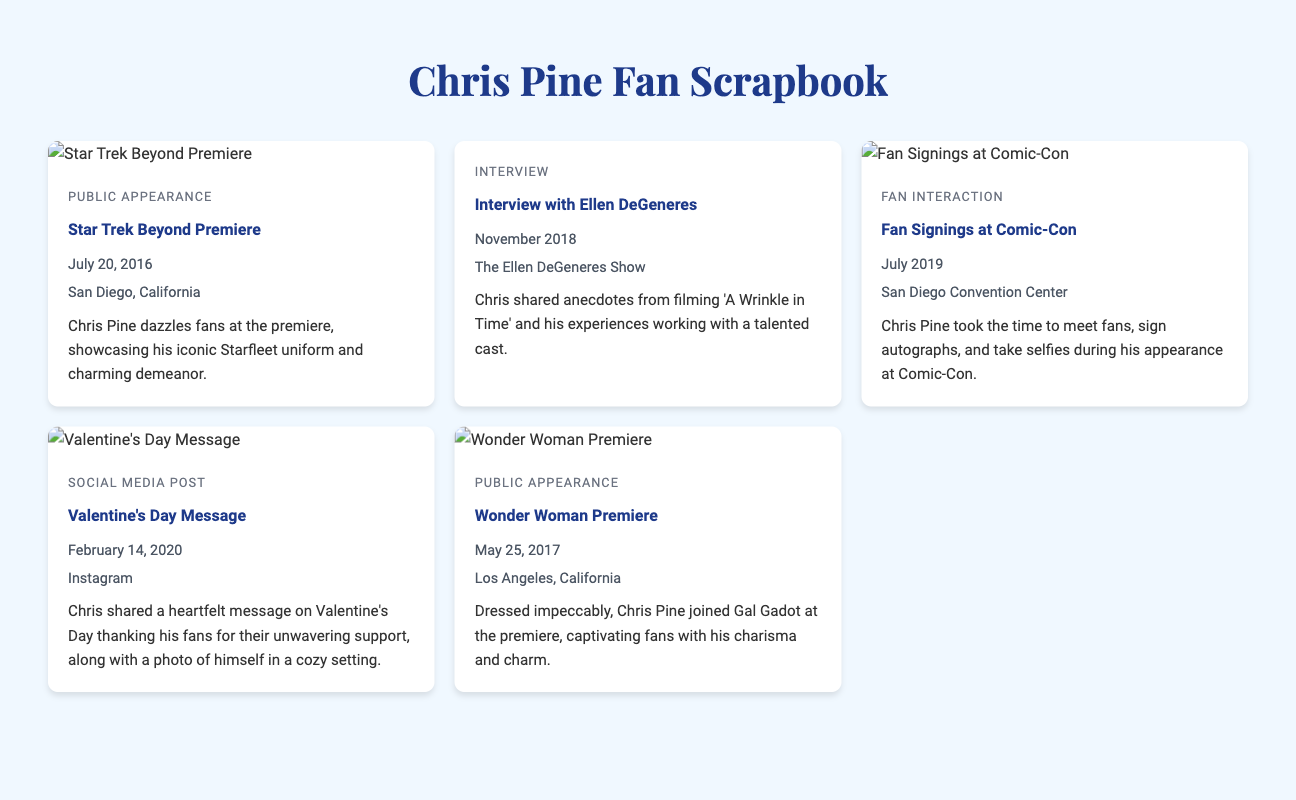What was the date of the Star Trek Beyond Premiere? The date is provided in the scrapbook item for the Star Trek Beyond Premiere.
Answer: July 20, 2016 Where did the Fan Signings at Comic-Con take place? The location is mentioned in the scrapbook item for the Fan Signings at Comic-Con.
Answer: San Diego Convention Center Which TV show featured Chris Pine in an interview in November 2018? The scrapbook item for the interview indicates the TV show he appeared on.
Answer: The Ellen DeGeneres Show What was the event type for Chris Pine's Valentine's Day message? The scrapbook describes the type of event for Chris Pine's social media post.
Answer: Social Media Post Who did Chris Pine attend the Wonder Woman Premiere with? The scrapbook item details who Chris Pine joined at the premiere.
Answer: Gal Gadot How many scrapbook items feature public appearances? The number of items categorized as public appearances is counted from the document.
Answer: 3 What type of content does Chris Pine share on Instagram on February 14, 2020? The scrapbook notes the nature of Chris's Instagram content on that date.
Answer: Heartfelt message Which event took place in July 2019? The date and event type are found in the scrapbook for that particular month.
Answer: Fan Signings at Comic-Con What is the main theme of the scrapbook? The document centers around Chris Pine's engagement with fans, appearances, and interviews.
Answer: Chris Pine's public appearances 